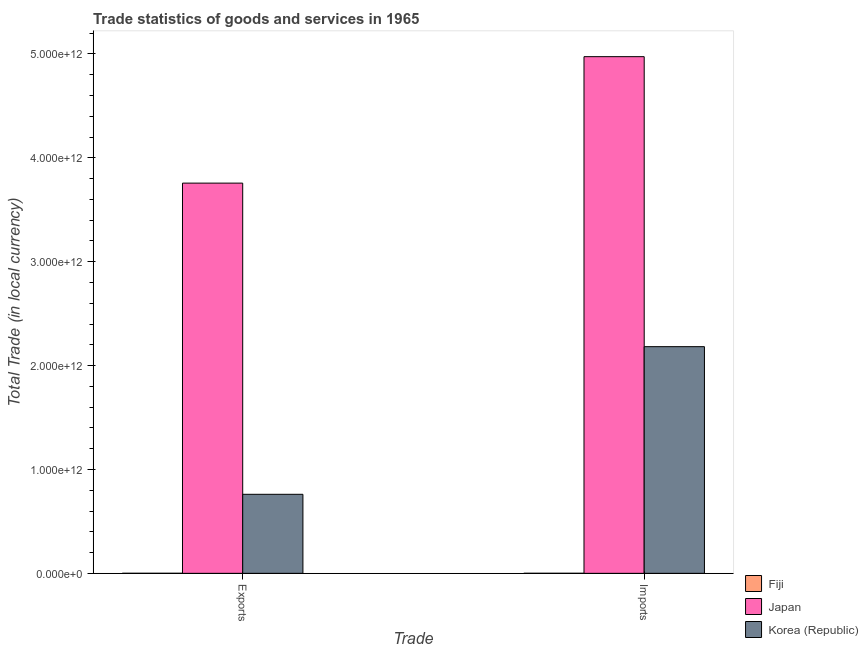How many groups of bars are there?
Keep it short and to the point. 2. Are the number of bars per tick equal to the number of legend labels?
Provide a short and direct response. Yes. Are the number of bars on each tick of the X-axis equal?
Your answer should be compact. Yes. How many bars are there on the 2nd tick from the left?
Provide a short and direct response. 3. How many bars are there on the 1st tick from the right?
Provide a succinct answer. 3. What is the label of the 2nd group of bars from the left?
Provide a short and direct response. Imports. What is the export of goods and services in Japan?
Offer a terse response. 3.76e+12. Across all countries, what is the maximum imports of goods and services?
Offer a terse response. 4.97e+12. Across all countries, what is the minimum imports of goods and services?
Keep it short and to the point. 4.05e+08. In which country was the export of goods and services maximum?
Your answer should be very brief. Japan. In which country was the export of goods and services minimum?
Make the answer very short. Fiji. What is the total imports of goods and services in the graph?
Give a very brief answer. 7.16e+12. What is the difference between the export of goods and services in Korea (Republic) and that in Japan?
Keep it short and to the point. -3.00e+12. What is the difference between the export of goods and services in Korea (Republic) and the imports of goods and services in Fiji?
Ensure brevity in your answer.  7.60e+11. What is the average export of goods and services per country?
Make the answer very short. 1.51e+12. What is the difference between the export of goods and services and imports of goods and services in Fiji?
Provide a succinct answer. 5.87e+07. In how many countries, is the export of goods and services greater than 3800000000000 LCU?
Offer a terse response. 0. What is the ratio of the export of goods and services in Fiji to that in Japan?
Offer a terse response. 0. In how many countries, is the export of goods and services greater than the average export of goods and services taken over all countries?
Make the answer very short. 1. What does the 3rd bar from the right in Imports represents?
Your answer should be very brief. Fiji. Are all the bars in the graph horizontal?
Your answer should be very brief. No. How many countries are there in the graph?
Ensure brevity in your answer.  3. What is the difference between two consecutive major ticks on the Y-axis?
Offer a terse response. 1.00e+12. Where does the legend appear in the graph?
Provide a succinct answer. Bottom right. How are the legend labels stacked?
Offer a very short reply. Vertical. What is the title of the graph?
Provide a short and direct response. Trade statistics of goods and services in 1965. What is the label or title of the X-axis?
Ensure brevity in your answer.  Trade. What is the label or title of the Y-axis?
Your response must be concise. Total Trade (in local currency). What is the Total Trade (in local currency) of Fiji in Exports?
Your answer should be very brief. 4.64e+08. What is the Total Trade (in local currency) in Japan in Exports?
Your answer should be very brief. 3.76e+12. What is the Total Trade (in local currency) in Korea (Republic) in Exports?
Offer a very short reply. 7.61e+11. What is the Total Trade (in local currency) of Fiji in Imports?
Your answer should be compact. 4.05e+08. What is the Total Trade (in local currency) of Japan in Imports?
Offer a very short reply. 4.97e+12. What is the Total Trade (in local currency) in Korea (Republic) in Imports?
Provide a succinct answer. 2.18e+12. Across all Trade, what is the maximum Total Trade (in local currency) of Fiji?
Your response must be concise. 4.64e+08. Across all Trade, what is the maximum Total Trade (in local currency) in Japan?
Offer a terse response. 4.97e+12. Across all Trade, what is the maximum Total Trade (in local currency) in Korea (Republic)?
Provide a short and direct response. 2.18e+12. Across all Trade, what is the minimum Total Trade (in local currency) in Fiji?
Ensure brevity in your answer.  4.05e+08. Across all Trade, what is the minimum Total Trade (in local currency) of Japan?
Your response must be concise. 3.76e+12. Across all Trade, what is the minimum Total Trade (in local currency) in Korea (Republic)?
Ensure brevity in your answer.  7.61e+11. What is the total Total Trade (in local currency) of Fiji in the graph?
Your answer should be very brief. 8.69e+08. What is the total Total Trade (in local currency) in Japan in the graph?
Your answer should be very brief. 8.73e+12. What is the total Total Trade (in local currency) of Korea (Republic) in the graph?
Your answer should be compact. 2.94e+12. What is the difference between the Total Trade (in local currency) of Fiji in Exports and that in Imports?
Provide a short and direct response. 5.87e+07. What is the difference between the Total Trade (in local currency) in Japan in Exports and that in Imports?
Your response must be concise. -1.22e+12. What is the difference between the Total Trade (in local currency) in Korea (Republic) in Exports and that in Imports?
Provide a succinct answer. -1.42e+12. What is the difference between the Total Trade (in local currency) of Fiji in Exports and the Total Trade (in local currency) of Japan in Imports?
Give a very brief answer. -4.97e+12. What is the difference between the Total Trade (in local currency) in Fiji in Exports and the Total Trade (in local currency) in Korea (Republic) in Imports?
Your answer should be compact. -2.18e+12. What is the difference between the Total Trade (in local currency) in Japan in Exports and the Total Trade (in local currency) in Korea (Republic) in Imports?
Offer a terse response. 1.57e+12. What is the average Total Trade (in local currency) in Fiji per Trade?
Provide a short and direct response. 4.34e+08. What is the average Total Trade (in local currency) of Japan per Trade?
Provide a succinct answer. 4.36e+12. What is the average Total Trade (in local currency) of Korea (Republic) per Trade?
Offer a terse response. 1.47e+12. What is the difference between the Total Trade (in local currency) in Fiji and Total Trade (in local currency) in Japan in Exports?
Provide a short and direct response. -3.76e+12. What is the difference between the Total Trade (in local currency) of Fiji and Total Trade (in local currency) of Korea (Republic) in Exports?
Offer a terse response. -7.60e+11. What is the difference between the Total Trade (in local currency) in Japan and Total Trade (in local currency) in Korea (Republic) in Exports?
Offer a terse response. 3.00e+12. What is the difference between the Total Trade (in local currency) of Fiji and Total Trade (in local currency) of Japan in Imports?
Offer a terse response. -4.97e+12. What is the difference between the Total Trade (in local currency) of Fiji and Total Trade (in local currency) of Korea (Republic) in Imports?
Your answer should be compact. -2.18e+12. What is the difference between the Total Trade (in local currency) of Japan and Total Trade (in local currency) of Korea (Republic) in Imports?
Make the answer very short. 2.79e+12. What is the ratio of the Total Trade (in local currency) in Fiji in Exports to that in Imports?
Provide a succinct answer. 1.14. What is the ratio of the Total Trade (in local currency) in Japan in Exports to that in Imports?
Offer a terse response. 0.76. What is the ratio of the Total Trade (in local currency) of Korea (Republic) in Exports to that in Imports?
Offer a terse response. 0.35. What is the difference between the highest and the second highest Total Trade (in local currency) in Fiji?
Offer a very short reply. 5.87e+07. What is the difference between the highest and the second highest Total Trade (in local currency) in Japan?
Provide a succinct answer. 1.22e+12. What is the difference between the highest and the second highest Total Trade (in local currency) in Korea (Republic)?
Make the answer very short. 1.42e+12. What is the difference between the highest and the lowest Total Trade (in local currency) of Fiji?
Ensure brevity in your answer.  5.87e+07. What is the difference between the highest and the lowest Total Trade (in local currency) of Japan?
Your answer should be compact. 1.22e+12. What is the difference between the highest and the lowest Total Trade (in local currency) in Korea (Republic)?
Keep it short and to the point. 1.42e+12. 